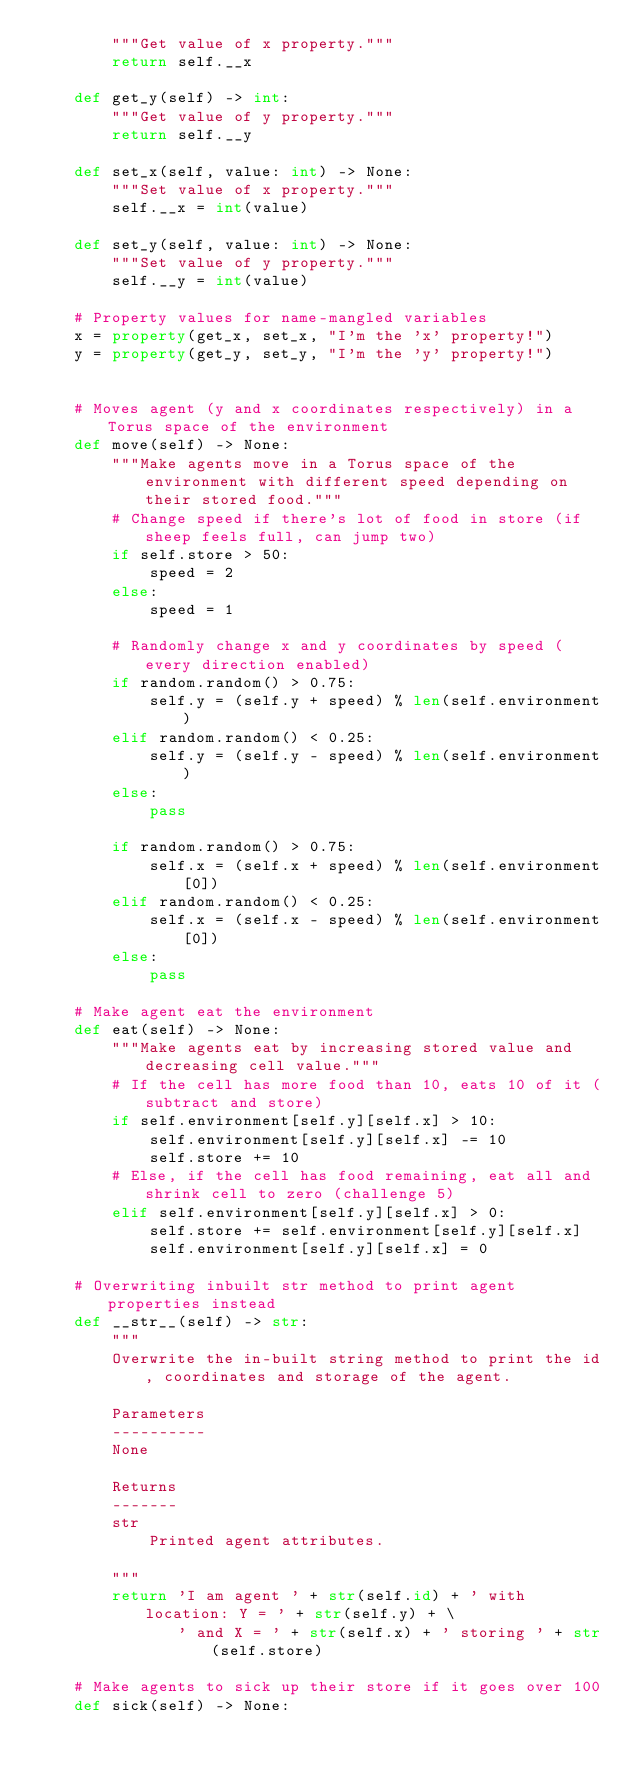<code> <loc_0><loc_0><loc_500><loc_500><_Python_>        """Get value of x property."""
        return self.__x

    def get_y(self) -> int:
        """Get value of y property."""
        return self.__y

    def set_x(self, value: int) -> None:
        """Set value of x property."""
        self.__x = int(value)

    def set_y(self, value: int) -> None:
        """Set value of y property."""
        self.__y = int(value)

    # Property values for name-mangled variables
    x = property(get_x, set_x, "I'm the 'x' property!")
    y = property(get_y, set_y, "I'm the 'y' property!")


    # Moves agent (y and x coordinates respectively) in a Torus space of the environment
    def move(self) -> None:
        """Make agents move in a Torus space of the environment with different speed depending on their stored food."""
        # Change speed if there's lot of food in store (if sheep feels full, can jump two)
        if self.store > 50:
            speed = 2
        else:
            speed = 1
        
        # Randomly change x and y coordinates by speed (every direction enabled)
        if random.random() > 0.75:
            self.y = (self.y + speed) % len(self.environment)
        elif random.random() < 0.25:
            self.y = (self.y - speed) % len(self.environment)
        else:
            pass

        if random.random() > 0.75:
            self.x = (self.x + speed) % len(self.environment[0])
        elif random.random() < 0.25:
            self.x = (self.x - speed) % len(self.environment[0])
        else:
            pass

    # Make agent eat the environment
    def eat(self) -> None:
        """Make agents eat by increasing stored value and decreasing cell value."""
        # If the cell has more food than 10, eats 10 of it (subtract and store)
        if self.environment[self.y][self.x] > 10:
            self.environment[self.y][self.x] -= 10
            self.store += 10
        # Else, if the cell has food remaining, eat all and shrink cell to zero (challenge 5)
        elif self.environment[self.y][self.x] > 0:
            self.store += self.environment[self.y][self.x]
            self.environment[self.y][self.x] = 0

    # Overwriting inbuilt str method to print agent properties instead
    def __str__(self) -> str:
        """
        Overwrite the in-built string method to print the id, coordinates and storage of the agent.

        Parameters
        ----------
        None

        Returns
        -------
        str
            Printed agent attributes.
        
        """
        return 'I am agent ' + str(self.id) + ' with location: Y = ' + str(self.y) + \
               ' and X = ' + str(self.x) + ' storing ' + str(self.store)

    # Make agents to sick up their store if it goes over 100
    def sick(self) -> None:</code> 